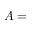Convert formula to latex. <formula><loc_0><loc_0><loc_500><loc_500>A =</formula> 